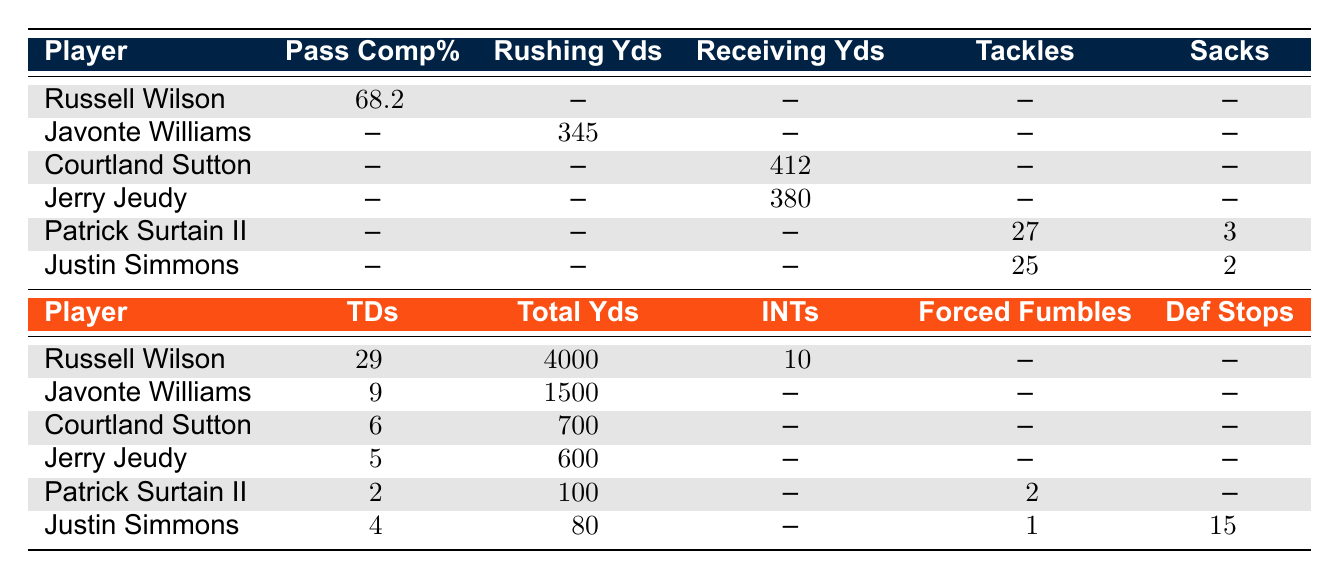What is the highest Pass Completion Rate among the players? The table shows that Russell Wilson has a Pass Completion Rate of 68.2%. The other players do not have any recorded values, making his the highest.
Answer: 68.2% How many Rushing Yards did Javonte Williams gain in Training Camp? The table lists Javonte Williams with Rushing Yards totaled at 345.
Answer: 345 Which player recorded the most tackles in Training Camp? Patrick Surtain II recorded 27 tackles, which is more than Justin Simmons' 25. Thus, he has the most tackles among the players.
Answer: Patrick Surtain II Did Jerry Jeudy score more touchdowns in the regular season than Courtland Sutton? Jerry Jeudy scored 5 touchdowns while Courtland Sutton scored 6. Therefore, he did not score more than Sutton.
Answer: No What is the total number of combined touchdowns for both Russell Wilson and Javonte Williams? Russell Wilson scored 29 touchdowns and Javonte Williams scored 9, giving a total of 29 + 9 = 38 touchdowns.
Answer: 38 Is there a player who has both Defensive Stops and Sacks recorded? Looking at the table, only Justin Simmons has recorded Defensive Stops (15) and Sacks (2), confirming that at least one player holds both metrics.
Answer: Yes What is the average Total Yards gained by the players listed? The Total Yards for the players are 4000 (Russell Wilson), 1500 (Javonte Williams), 700 (Courtland Sutton), 600 (Jerry Jeudy), 100 (Patrick Surtain II), and 80 (Justin Simmons). The average is calculated by summing these values (4000 + 1500 + 700 + 600 + 100 + 80 = 6400) and dividing by the number of players (6). 6400 / 6 ≈ 1066.67.
Answer: 1066.67 How many players have Rushing Yards recorded during Training Camp? Only one player, Javonte Williams, is shown to have Rushing Yards listed in the table.
Answer: 1 Which player has the lowest Total Yards in the regular season? Among the players listed, Justin Simmons has the lowest Total Yards at 80.
Answer: Justin Simmons 